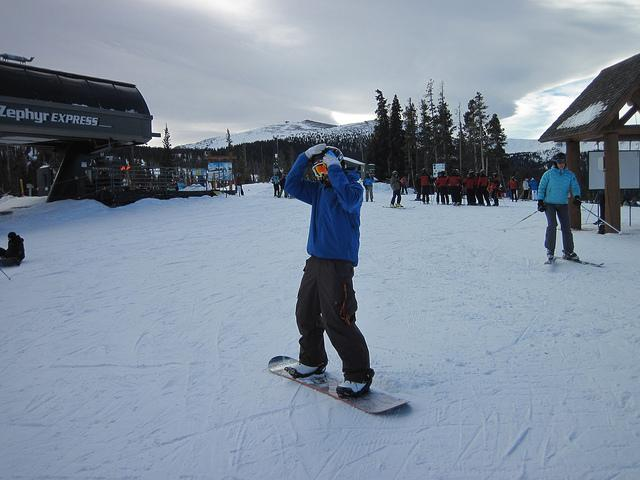What do these men plan to do here?

Choices:
A) ski
B) hike
C) run
D) swim ski 